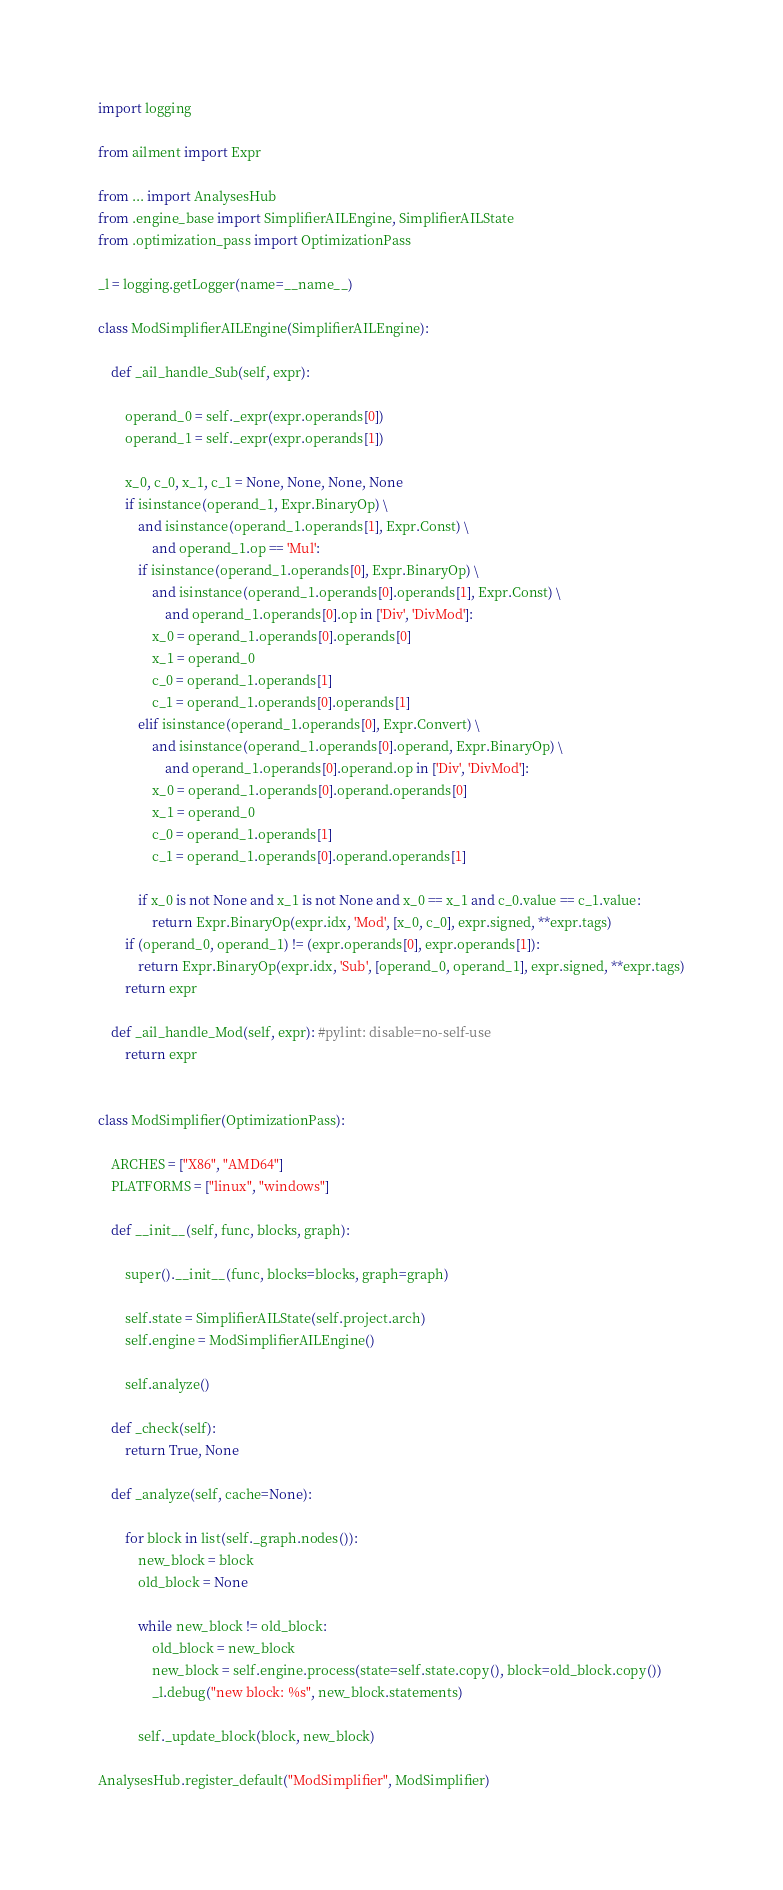Convert code to text. <code><loc_0><loc_0><loc_500><loc_500><_Python_>import logging

from ailment import Expr

from ... import AnalysesHub
from .engine_base import SimplifierAILEngine, SimplifierAILState
from .optimization_pass import OptimizationPass

_l = logging.getLogger(name=__name__)

class ModSimplifierAILEngine(SimplifierAILEngine):

    def _ail_handle_Sub(self, expr):

        operand_0 = self._expr(expr.operands[0])
        operand_1 = self._expr(expr.operands[1])

        x_0, c_0, x_1, c_1 = None, None, None, None
        if isinstance(operand_1, Expr.BinaryOp) \
            and isinstance(operand_1.operands[1], Expr.Const) \
                and operand_1.op == 'Mul':
            if isinstance(operand_1.operands[0], Expr.BinaryOp) \
                and isinstance(operand_1.operands[0].operands[1], Expr.Const) \
                    and operand_1.operands[0].op in ['Div', 'DivMod']:
                x_0 = operand_1.operands[0].operands[0]
                x_1 = operand_0
                c_0 = operand_1.operands[1]
                c_1 = operand_1.operands[0].operands[1]
            elif isinstance(operand_1.operands[0], Expr.Convert) \
                and isinstance(operand_1.operands[0].operand, Expr.BinaryOp) \
                    and operand_1.operands[0].operand.op in ['Div', 'DivMod']:
                x_0 = operand_1.operands[0].operand.operands[0]
                x_1 = operand_0
                c_0 = operand_1.operands[1]
                c_1 = operand_1.operands[0].operand.operands[1]

            if x_0 is not None and x_1 is not None and x_0 == x_1 and c_0.value == c_1.value:
                return Expr.BinaryOp(expr.idx, 'Mod', [x_0, c_0], expr.signed, **expr.tags)
        if (operand_0, operand_1) != (expr.operands[0], expr.operands[1]):
            return Expr.BinaryOp(expr.idx, 'Sub', [operand_0, operand_1], expr.signed, **expr.tags)
        return expr

    def _ail_handle_Mod(self, expr): #pylint: disable=no-self-use
        return expr


class ModSimplifier(OptimizationPass):

    ARCHES = ["X86", "AMD64"]
    PLATFORMS = ["linux", "windows"]

    def __init__(self, func, blocks, graph):

        super().__init__(func, blocks=blocks, graph=graph)

        self.state = SimplifierAILState(self.project.arch)
        self.engine = ModSimplifierAILEngine()

        self.analyze()

    def _check(self):
        return True, None

    def _analyze(self, cache=None):

        for block in list(self._graph.nodes()):
            new_block = block
            old_block = None

            while new_block != old_block:
                old_block = new_block
                new_block = self.engine.process(state=self.state.copy(), block=old_block.copy())
                _l.debug("new block: %s", new_block.statements)

            self._update_block(block, new_block)

AnalysesHub.register_default("ModSimplifier", ModSimplifier)
</code> 